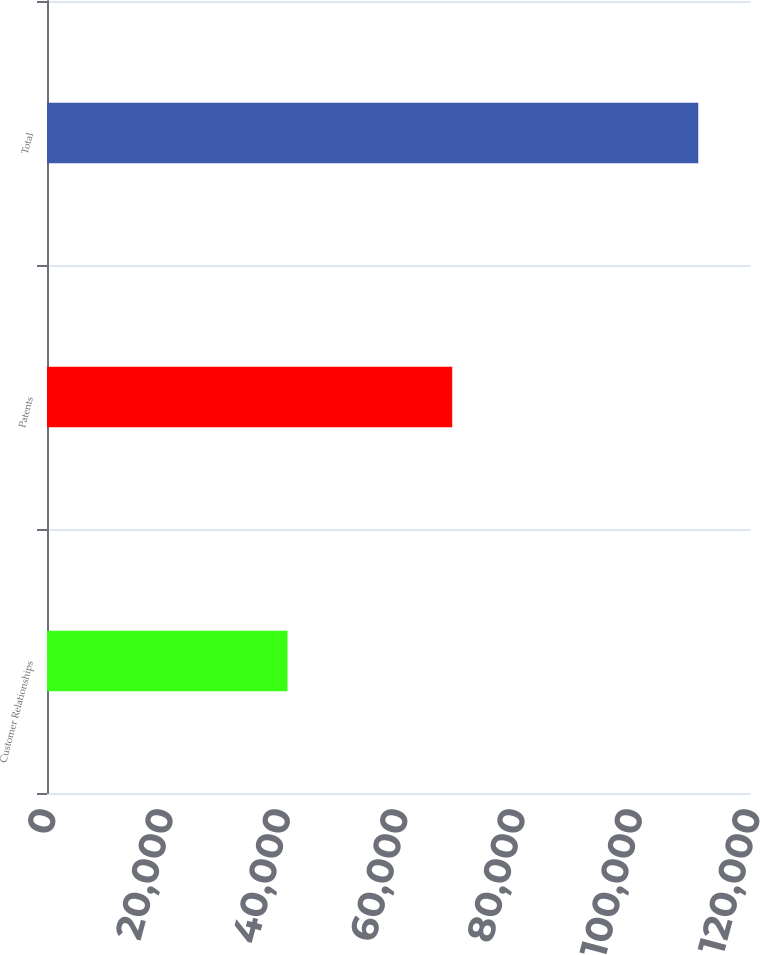Convert chart to OTSL. <chart><loc_0><loc_0><loc_500><loc_500><bar_chart><fcel>Customer Relationships<fcel>Patents<fcel>Total<nl><fcel>40998<fcel>69071<fcel>111010<nl></chart> 